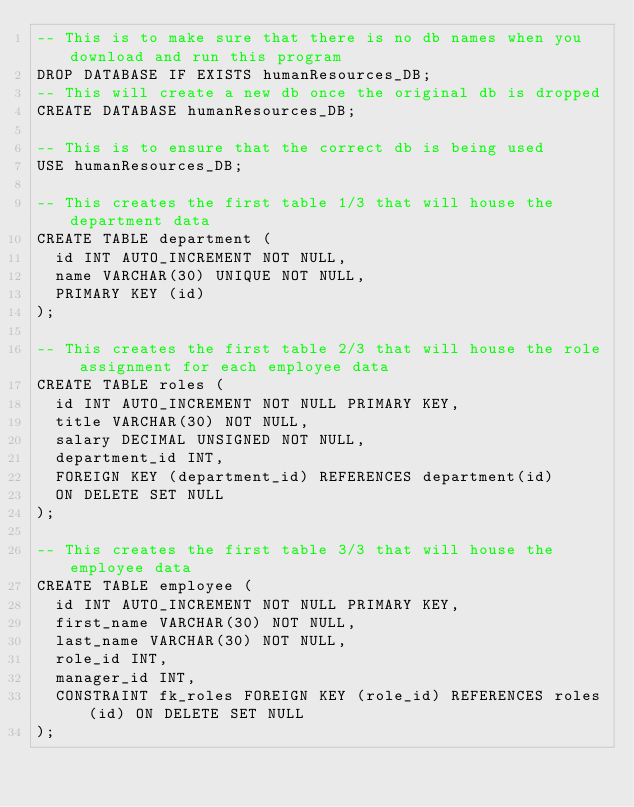Convert code to text. <code><loc_0><loc_0><loc_500><loc_500><_SQL_>-- This is to make sure that there is no db names when you download and run this program
DROP DATABASE IF EXISTS humanResources_DB;
-- This will create a new db once the original db is dropped
CREATE DATABASE humanResources_DB;

-- This is to ensure that the correct db is being used
USE humanResources_DB;

-- This creates the first table 1/3 that will house the department data
CREATE TABLE department (
  id INT AUTO_INCREMENT NOT NULL,
  name VARCHAR(30) UNIQUE NOT NULL,
  PRIMARY KEY (id)
);

-- This creates the first table 2/3 that will house the role assignment for each employee data
CREATE TABLE roles (
  id INT AUTO_INCREMENT NOT NULL PRIMARY KEY,
  title VARCHAR(30) NOT NULL,
  salary DECIMAL UNSIGNED NOT NULL,
  department_id INT,
  FOREIGN KEY (department_id) REFERENCES department(id)
  ON DELETE SET NULL
);

-- This creates the first table 3/3 that will house the employee data
CREATE TABLE employee (
  id INT AUTO_INCREMENT NOT NULL PRIMARY KEY,
  first_name VARCHAR(30) NOT NULL,
  last_name VARCHAR(30) NOT NULL,
  role_id INT,
  manager_id INT,
  CONSTRAINT fk_roles FOREIGN KEY (role_id) REFERENCES roles(id) ON DELETE SET NULL
);</code> 